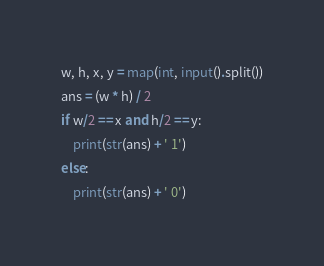<code> <loc_0><loc_0><loc_500><loc_500><_Python_>w, h, x, y = map(int, input().split())
ans = (w * h) / 2
if w/2 == x and h/2 == y:
    print(str(ans) + ' 1')
else:
    print(str(ans) + ' 0')</code> 